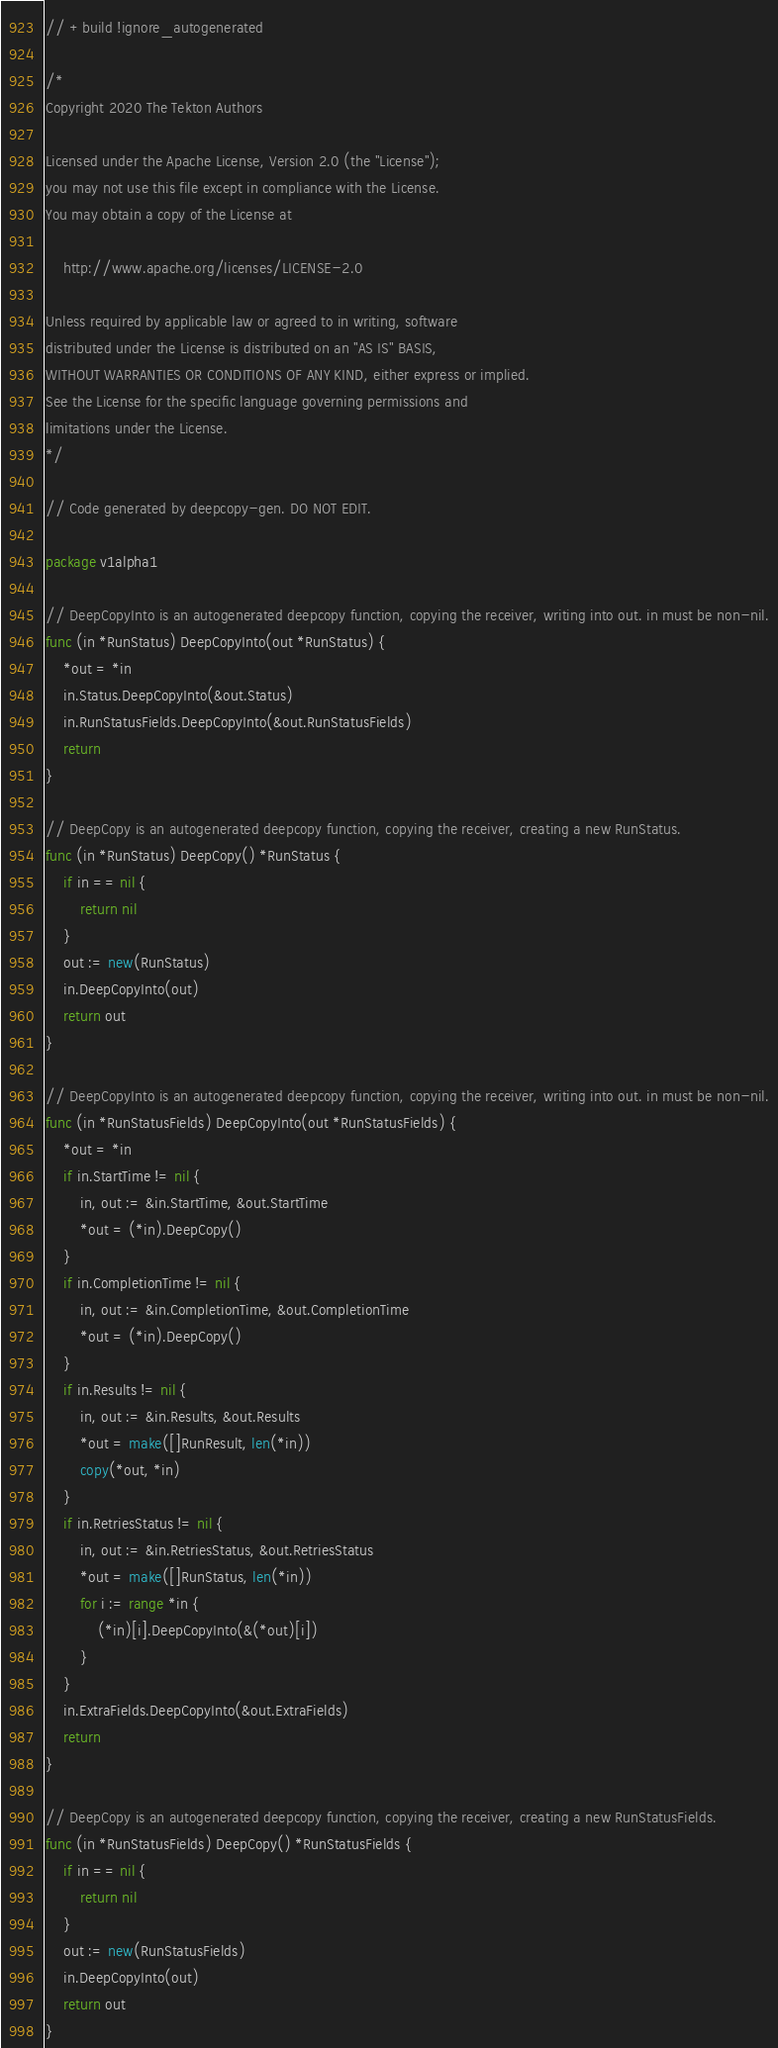Convert code to text. <code><loc_0><loc_0><loc_500><loc_500><_Go_>// +build !ignore_autogenerated

/*
Copyright 2020 The Tekton Authors

Licensed under the Apache License, Version 2.0 (the "License");
you may not use this file except in compliance with the License.
You may obtain a copy of the License at

    http://www.apache.org/licenses/LICENSE-2.0

Unless required by applicable law or agreed to in writing, software
distributed under the License is distributed on an "AS IS" BASIS,
WITHOUT WARRANTIES OR CONDITIONS OF ANY KIND, either express or implied.
See the License for the specific language governing permissions and
limitations under the License.
*/

// Code generated by deepcopy-gen. DO NOT EDIT.

package v1alpha1

// DeepCopyInto is an autogenerated deepcopy function, copying the receiver, writing into out. in must be non-nil.
func (in *RunStatus) DeepCopyInto(out *RunStatus) {
	*out = *in
	in.Status.DeepCopyInto(&out.Status)
	in.RunStatusFields.DeepCopyInto(&out.RunStatusFields)
	return
}

// DeepCopy is an autogenerated deepcopy function, copying the receiver, creating a new RunStatus.
func (in *RunStatus) DeepCopy() *RunStatus {
	if in == nil {
		return nil
	}
	out := new(RunStatus)
	in.DeepCopyInto(out)
	return out
}

// DeepCopyInto is an autogenerated deepcopy function, copying the receiver, writing into out. in must be non-nil.
func (in *RunStatusFields) DeepCopyInto(out *RunStatusFields) {
	*out = *in
	if in.StartTime != nil {
		in, out := &in.StartTime, &out.StartTime
		*out = (*in).DeepCopy()
	}
	if in.CompletionTime != nil {
		in, out := &in.CompletionTime, &out.CompletionTime
		*out = (*in).DeepCopy()
	}
	if in.Results != nil {
		in, out := &in.Results, &out.Results
		*out = make([]RunResult, len(*in))
		copy(*out, *in)
	}
	if in.RetriesStatus != nil {
		in, out := &in.RetriesStatus, &out.RetriesStatus
		*out = make([]RunStatus, len(*in))
		for i := range *in {
			(*in)[i].DeepCopyInto(&(*out)[i])
		}
	}
	in.ExtraFields.DeepCopyInto(&out.ExtraFields)
	return
}

// DeepCopy is an autogenerated deepcopy function, copying the receiver, creating a new RunStatusFields.
func (in *RunStatusFields) DeepCopy() *RunStatusFields {
	if in == nil {
		return nil
	}
	out := new(RunStatusFields)
	in.DeepCopyInto(out)
	return out
}
</code> 